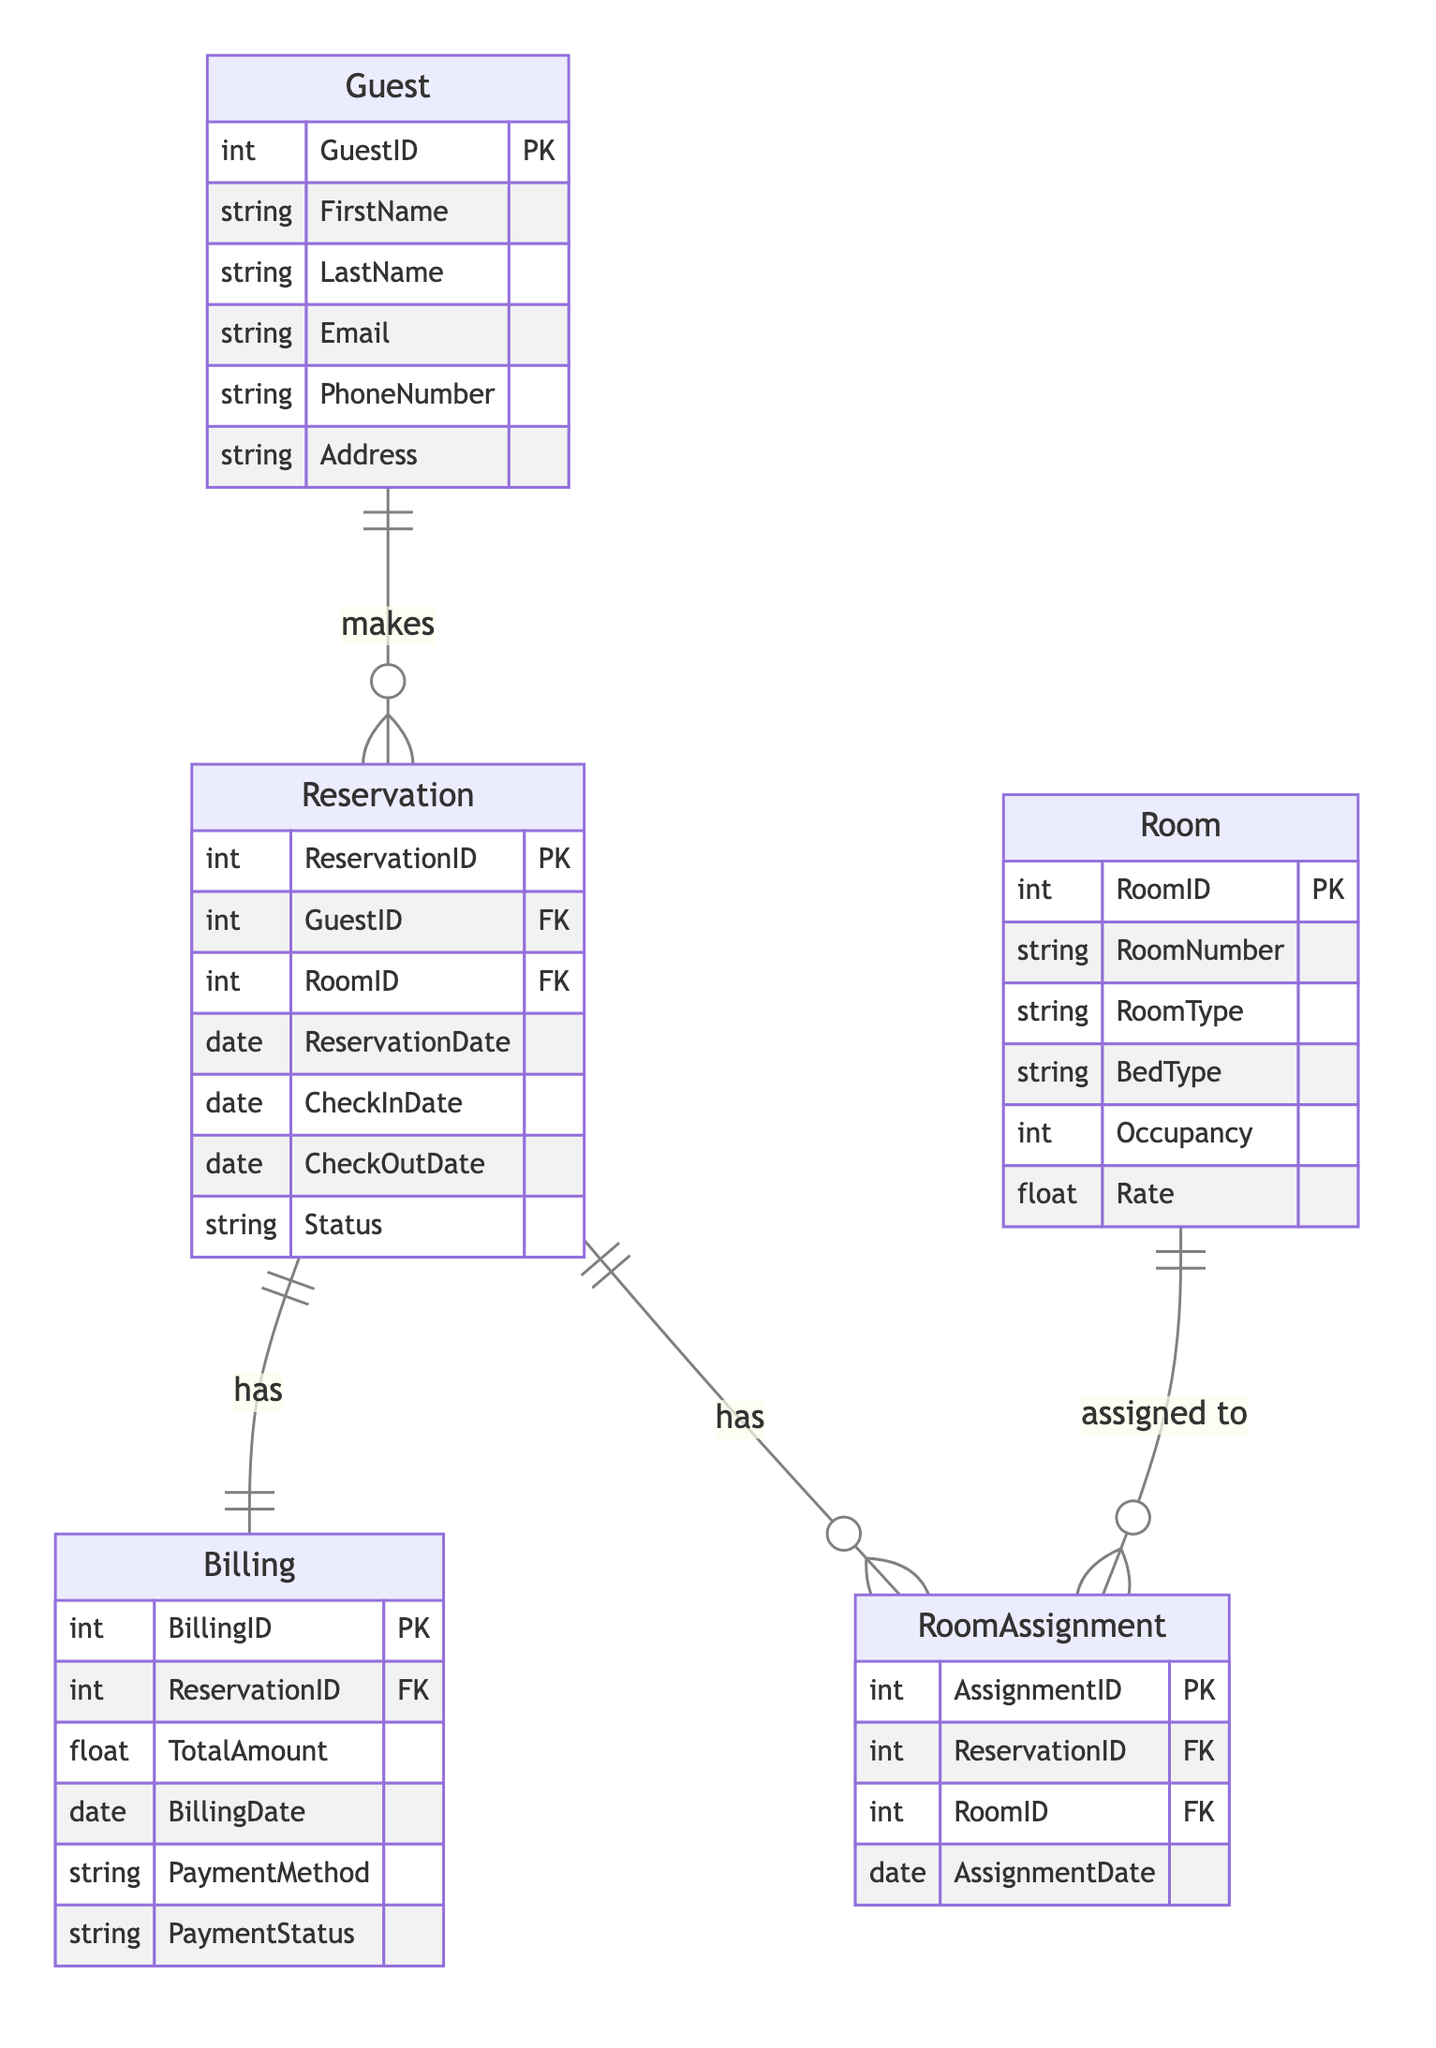What is the primary key of the Guest entity? The primary key of the Guest entity is GuestID, which uniquely identifies each guest in the database.
Answer: GuestID How many entities are defined in this diagram? The diagram contains five entities: Guest, Reservation, Room, Billing, and RoomAssignment.
Answer: 5 What type of relationship exists between Reservation and Billing? The relationship between Reservation and Billing is one-to-one, meaning each reservation corresponds to exactly one billing record.
Answer: one-to-one Which entity is related to RoomAssignment through its RoomID? The Room entity is related to RoomAssignment through its RoomID, indicating that a room can have multiple assignments.
Answer: Room How many attributes does the Reservation entity have? The Reservation entity has seven attributes, which are ReservationID, GuestID, RoomID, ReservationDate, CheckInDate, CheckOutDate, and Status.
Answer: 7 What is the foreign key in the Billing entity? The foreign key in the Billing entity is ReservationID, which references the Reservation entity to link the billing information with a specific reservation.
Answer: ReservationID Which entity makes a reservation? The Guest entity makes a reservation, establishing a one-to-many relationship where one guest can have multiple reservations.
Answer: Guest What is the total number of relationships in the diagram? There are four relationships in the diagram: Guest_Reservation, Reservation_RoomAssignment, Room_RoomAssignment, and Reservation_Billing.
Answer: 4 In the relationship between Guest and Reservation, how many reservations can one guest make? One guest can make multiple reservations, indicating a one-to-many relationship between Guest and Reservation.
Answer: multiple 